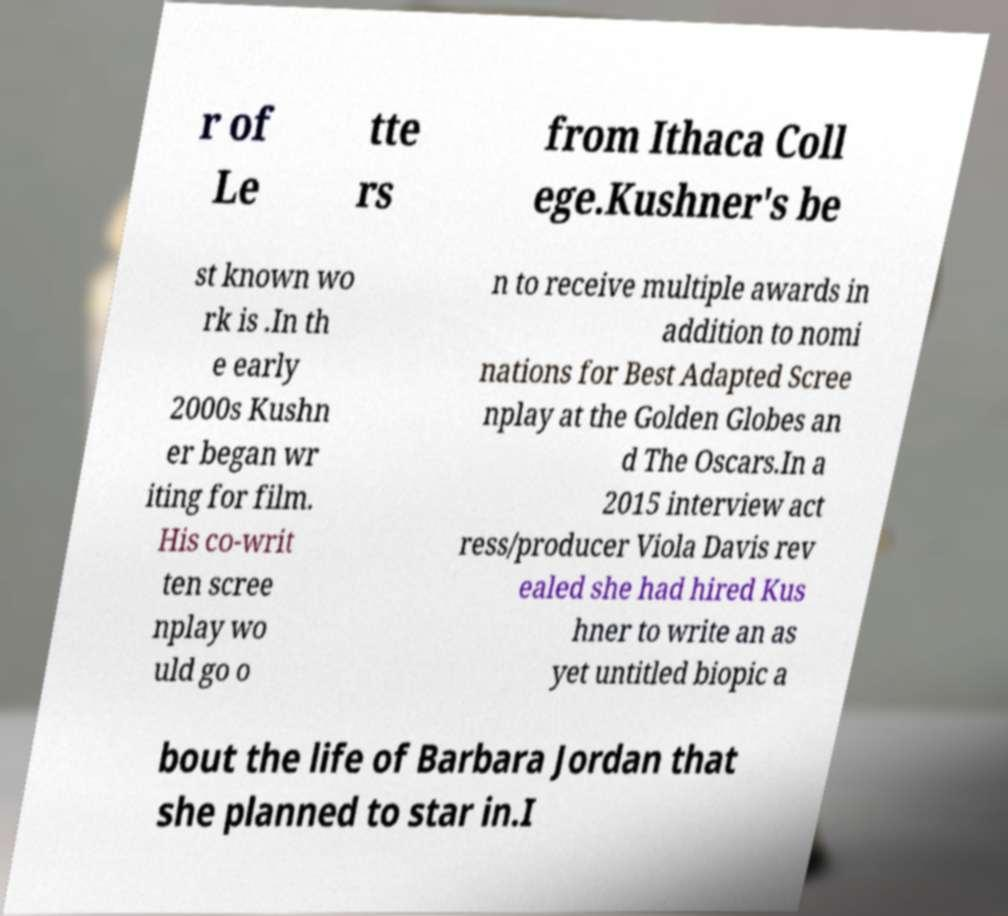Could you assist in decoding the text presented in this image and type it out clearly? r of Le tte rs from Ithaca Coll ege.Kushner's be st known wo rk is .In th e early 2000s Kushn er began wr iting for film. His co-writ ten scree nplay wo uld go o n to receive multiple awards in addition to nomi nations for Best Adapted Scree nplay at the Golden Globes an d The Oscars.In a 2015 interview act ress/producer Viola Davis rev ealed she had hired Kus hner to write an as yet untitled biopic a bout the life of Barbara Jordan that she planned to star in.I 